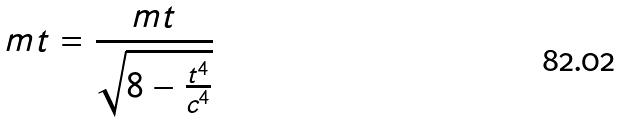<formula> <loc_0><loc_0><loc_500><loc_500>m t = \frac { m t } { \sqrt { 8 - \frac { t ^ { 4 } } { c ^ { 4 } } } }</formula> 